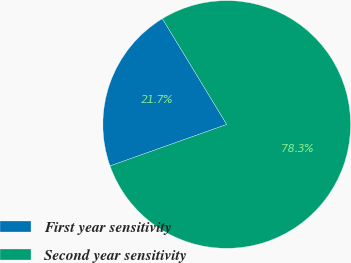Convert chart. <chart><loc_0><loc_0><loc_500><loc_500><pie_chart><fcel>First year sensitivity<fcel>Second year sensitivity<nl><fcel>21.74%<fcel>78.26%<nl></chart> 